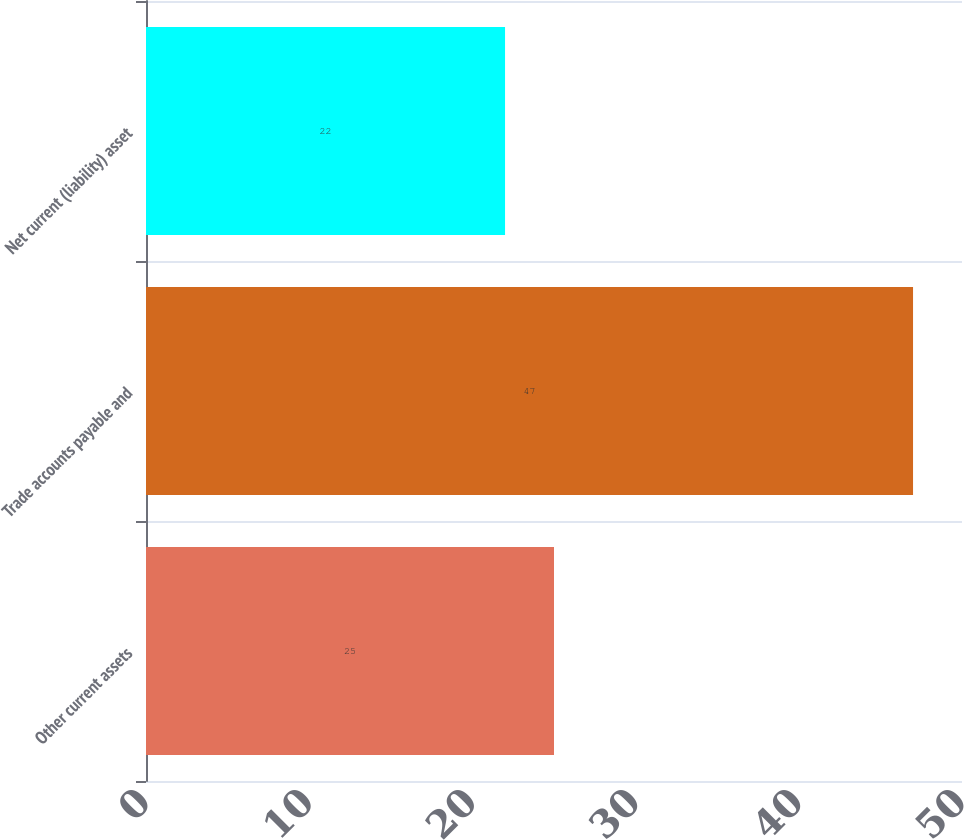Convert chart to OTSL. <chart><loc_0><loc_0><loc_500><loc_500><bar_chart><fcel>Other current assets<fcel>Trade accounts payable and<fcel>Net current (liability) asset<nl><fcel>25<fcel>47<fcel>22<nl></chart> 